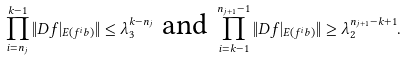Convert formula to latex. <formula><loc_0><loc_0><loc_500><loc_500>\prod _ { i = n _ { j } } ^ { k - 1 } \| D f | _ { E ( f ^ { i } b ) } \| \leq \lambda _ { 3 } ^ { k - n _ { j } } \text { and } \prod _ { i = k - 1 } ^ { n _ { j + 1 } - 1 } \| D f | _ { E ( f ^ { i } b ) } \| \geq \lambda _ { 2 } ^ { n _ { j + 1 } - k + 1 } .</formula> 